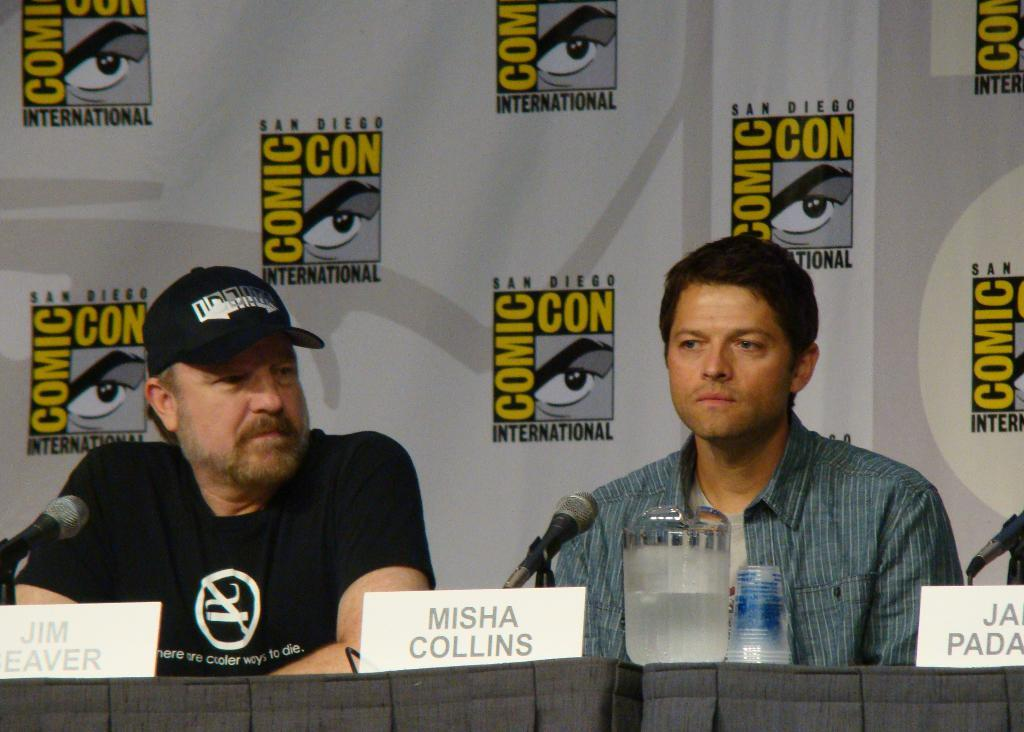<image>
Offer a succinct explanation of the picture presented. Two people are talking at a Comic Con table and their name placards say Jim Weaver and Misha Collins. 